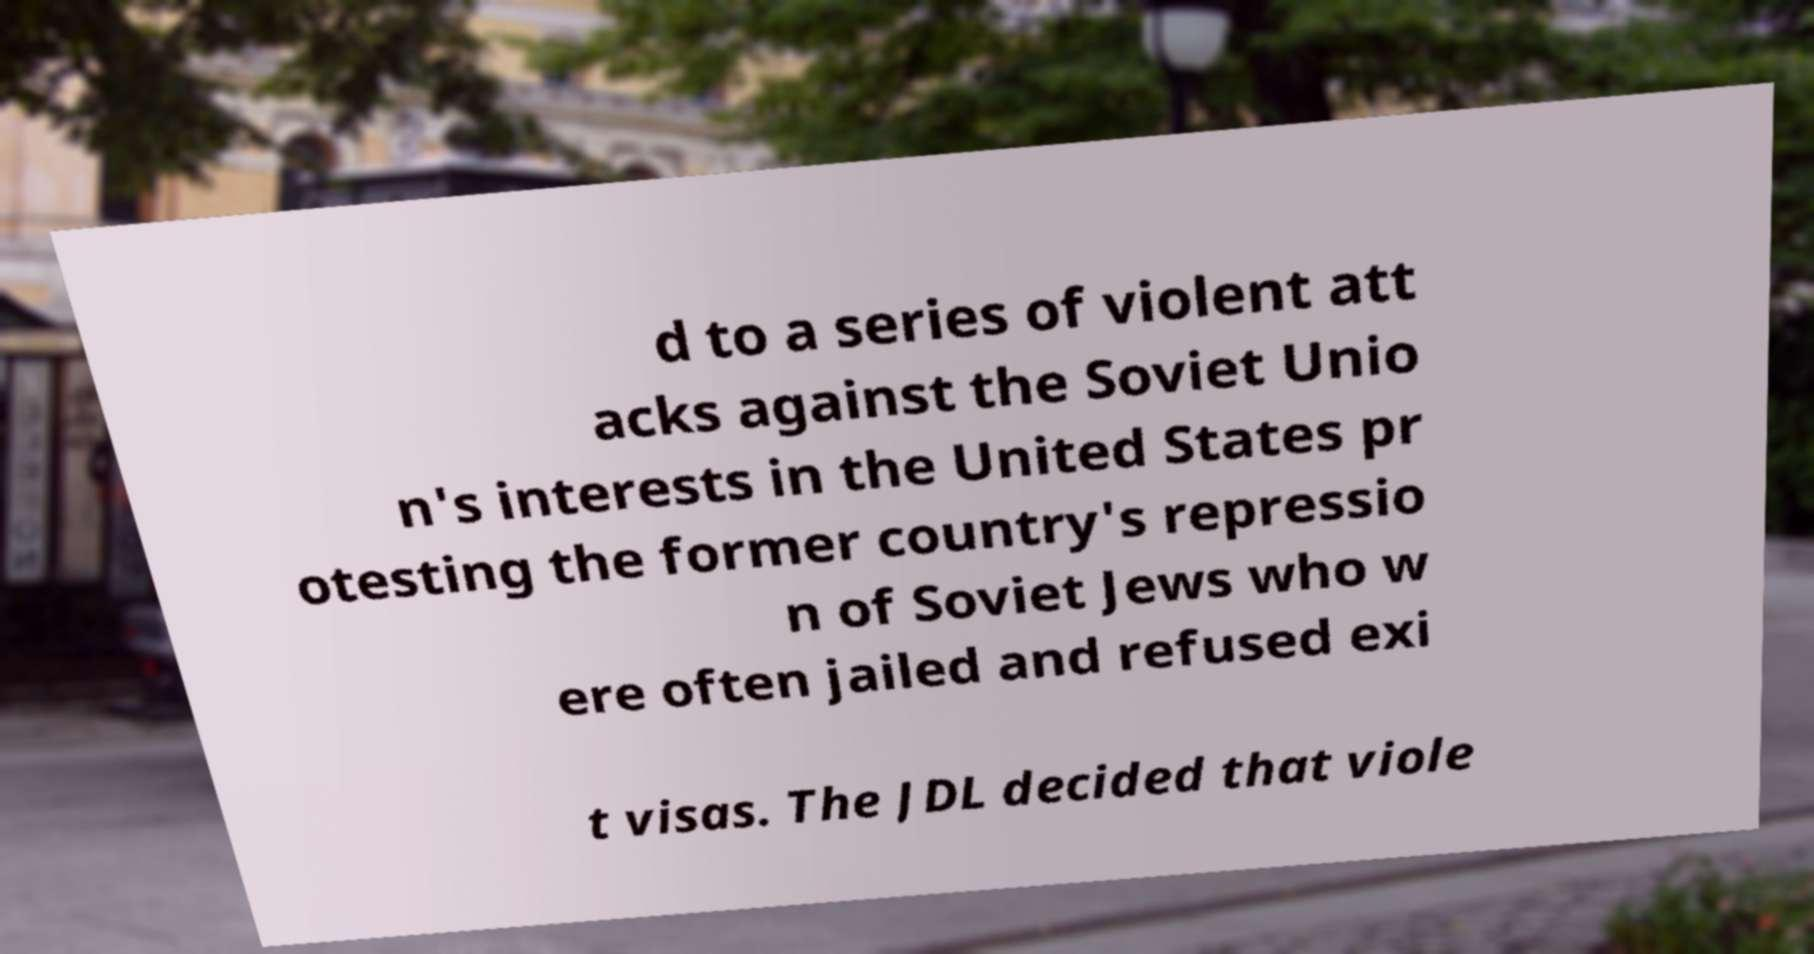Can you accurately transcribe the text from the provided image for me? d to a series of violent att acks against the Soviet Unio n's interests in the United States pr otesting the former country's repressio n of Soviet Jews who w ere often jailed and refused exi t visas. The JDL decided that viole 